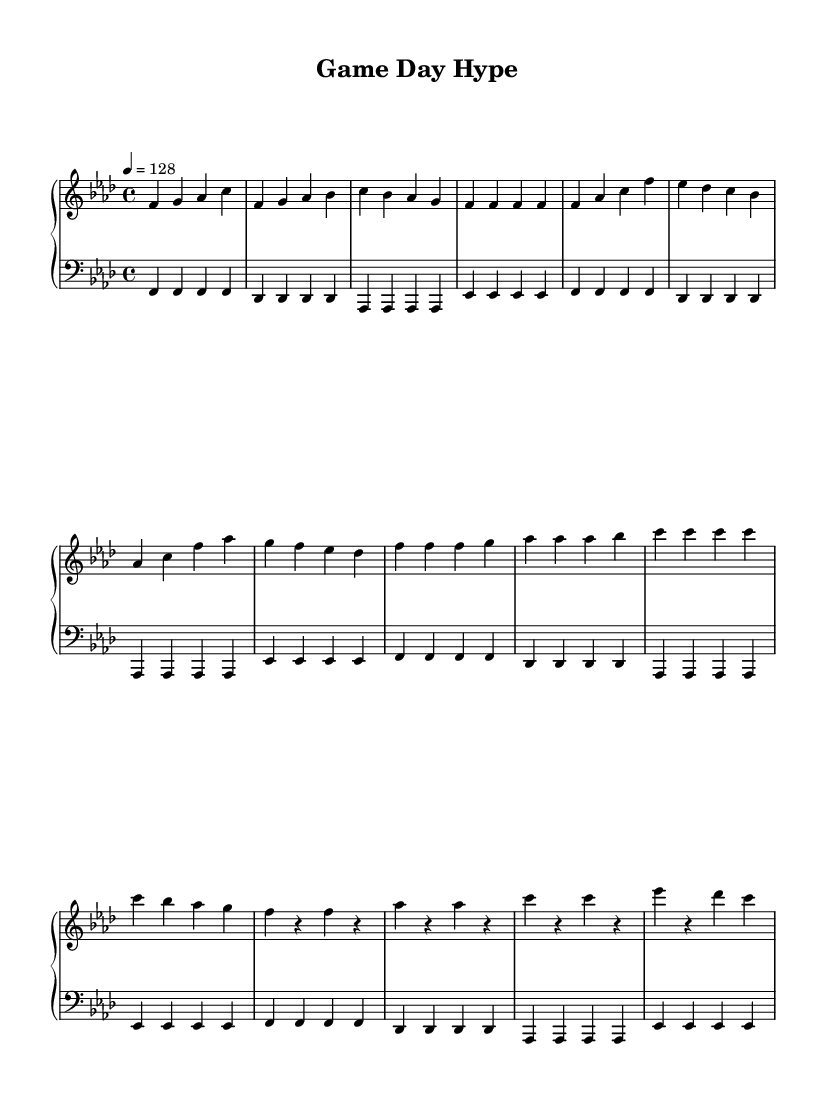What is the key signature of this music? The key signature is indicated by the number of flats present. In this case, the key signature has four flats, which corresponds to F minor.
Answer: F minor What is the time signature of this music? The time signature is indicated at the beginning of the score, shown as "4/4". This means there are four beats per measure, and a quarter note gets one beat.
Answer: 4/4 What is the tempo marking for this piece? The tempo marking can be found at the beginning of the music, where it states "4 = 128". This means there are 128 beats per minute, indicating a fast-paced rhythm suitable for high-energy music.
Answer: 128 How many measures are there in the verse section? The verse section consists of four measures, as indicated by the groupings of notes in the score. Each line of music represents a certain number of measures, in this case, those groupings can be counted to find the number of measures.
Answer: 4 What type of musical piece is this? The music is characterized by its energetic and upbeat nature, typical of electronic dance music, which is designed to pump up energy levels for pre-game sessions. This is reflected in the fast tempo and driving rhythm.
Answer: Electronic dance music Which section contains the drop? The drop section is indicated specifically within the overall structure of the piece. It's labeled as "Drop" within the score, which is a typical term used in electronic dance music to denote a high-energy moment after a build-up.
Answer: Drop What is the primary rhythm in the bass line? The primary rhythm in the bass line features a steady quarter note pattern throughout, creating a solid foundation for the higher melodies. This can be seen by analyzing how the notes are aligned and spaced in the bass staff portion of the score.
Answer: Quarter notes 